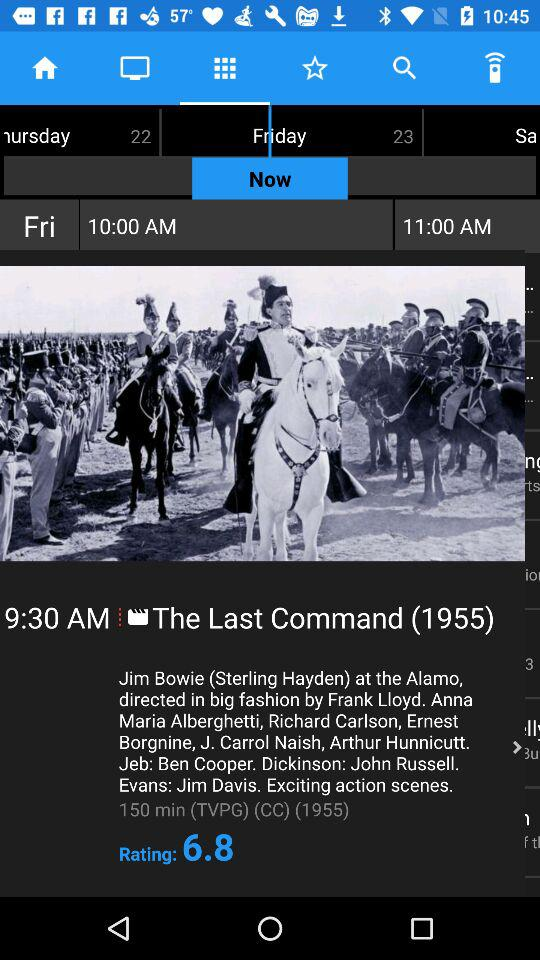What is the rating of the movie with the most reviews?
Answer the question using a single word or phrase. 6.8 